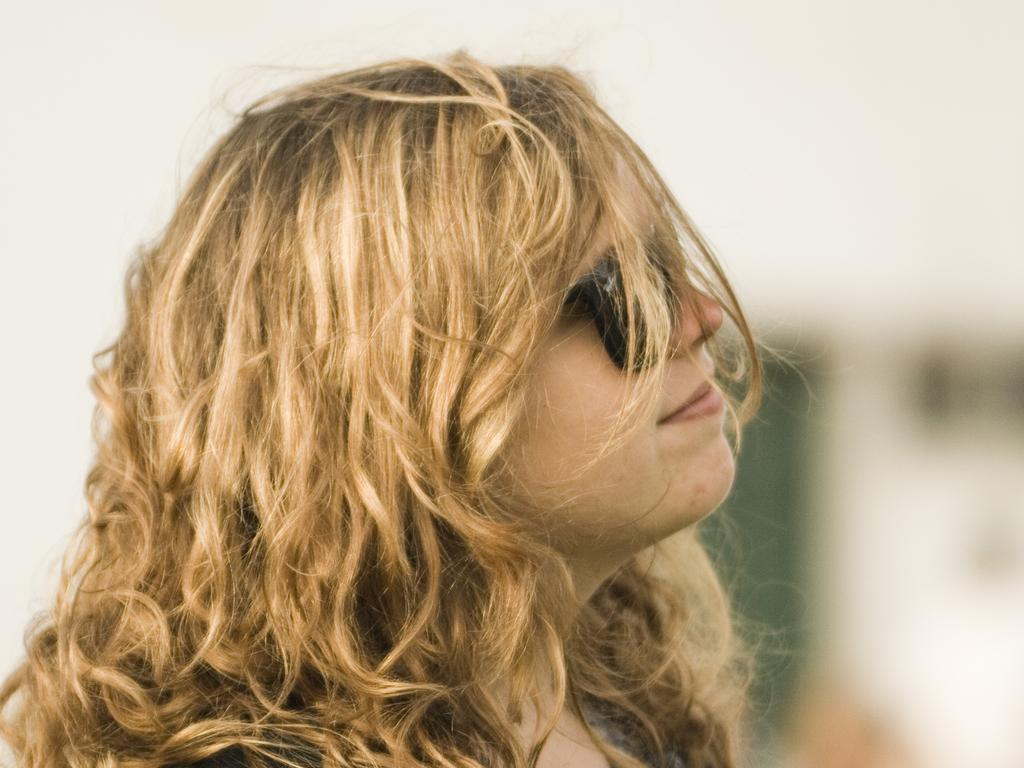Who is present in the image? There is a woman in the image. What is the woman wearing on her face? The woman is wearing sunglasses. Can you describe the background of the image? The background of the image is blurred. What type of blade can be seen in the woman's hand in the image? There is no blade present in the woman's hand or anywhere else in the image. 